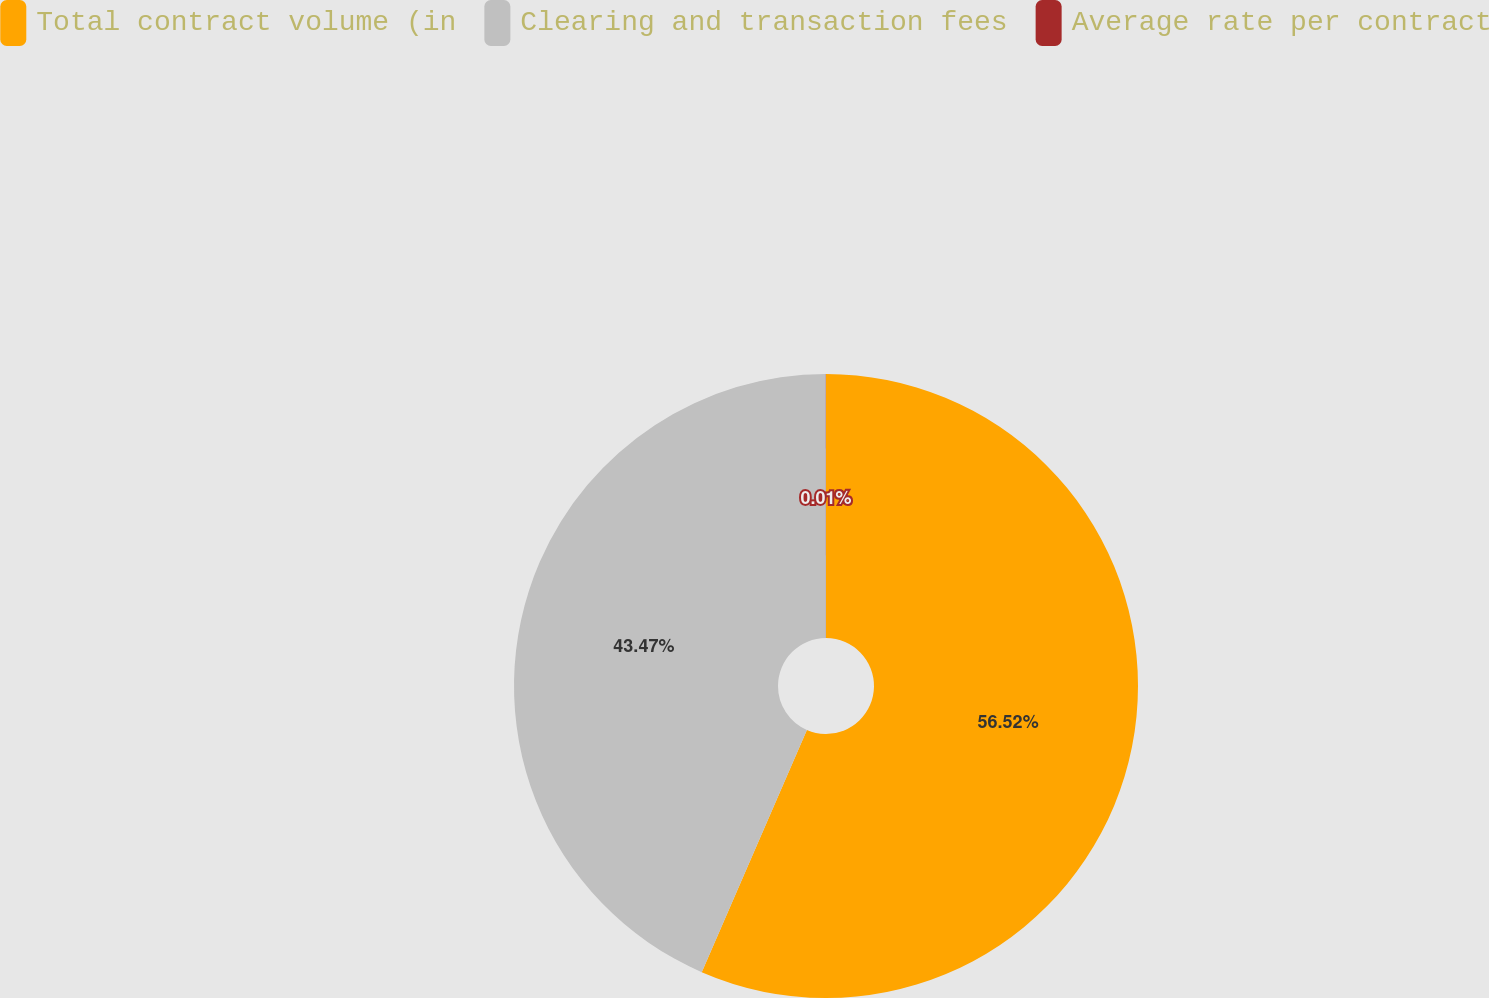Convert chart to OTSL. <chart><loc_0><loc_0><loc_500><loc_500><pie_chart><fcel>Total contract volume (in<fcel>Clearing and transaction fees<fcel>Average rate per contract<nl><fcel>56.52%<fcel>43.47%<fcel>0.01%<nl></chart> 